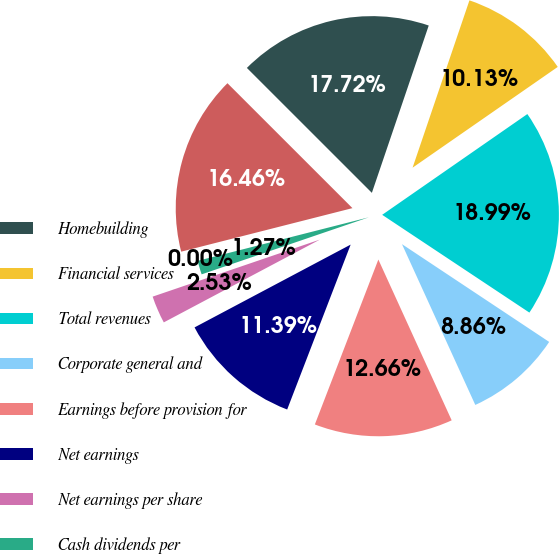<chart> <loc_0><loc_0><loc_500><loc_500><pie_chart><fcel>Homebuilding<fcel>Financial services<fcel>Total revenues<fcel>Corporate general and<fcel>Earnings before provision for<fcel>Net earnings<fcel>Net earnings per share<fcel>Cash dividends per<fcel>Cash dividends per share-Class<fcel>Total assets<nl><fcel>17.72%<fcel>10.13%<fcel>18.99%<fcel>8.86%<fcel>12.66%<fcel>11.39%<fcel>2.53%<fcel>1.27%<fcel>0.0%<fcel>16.46%<nl></chart> 